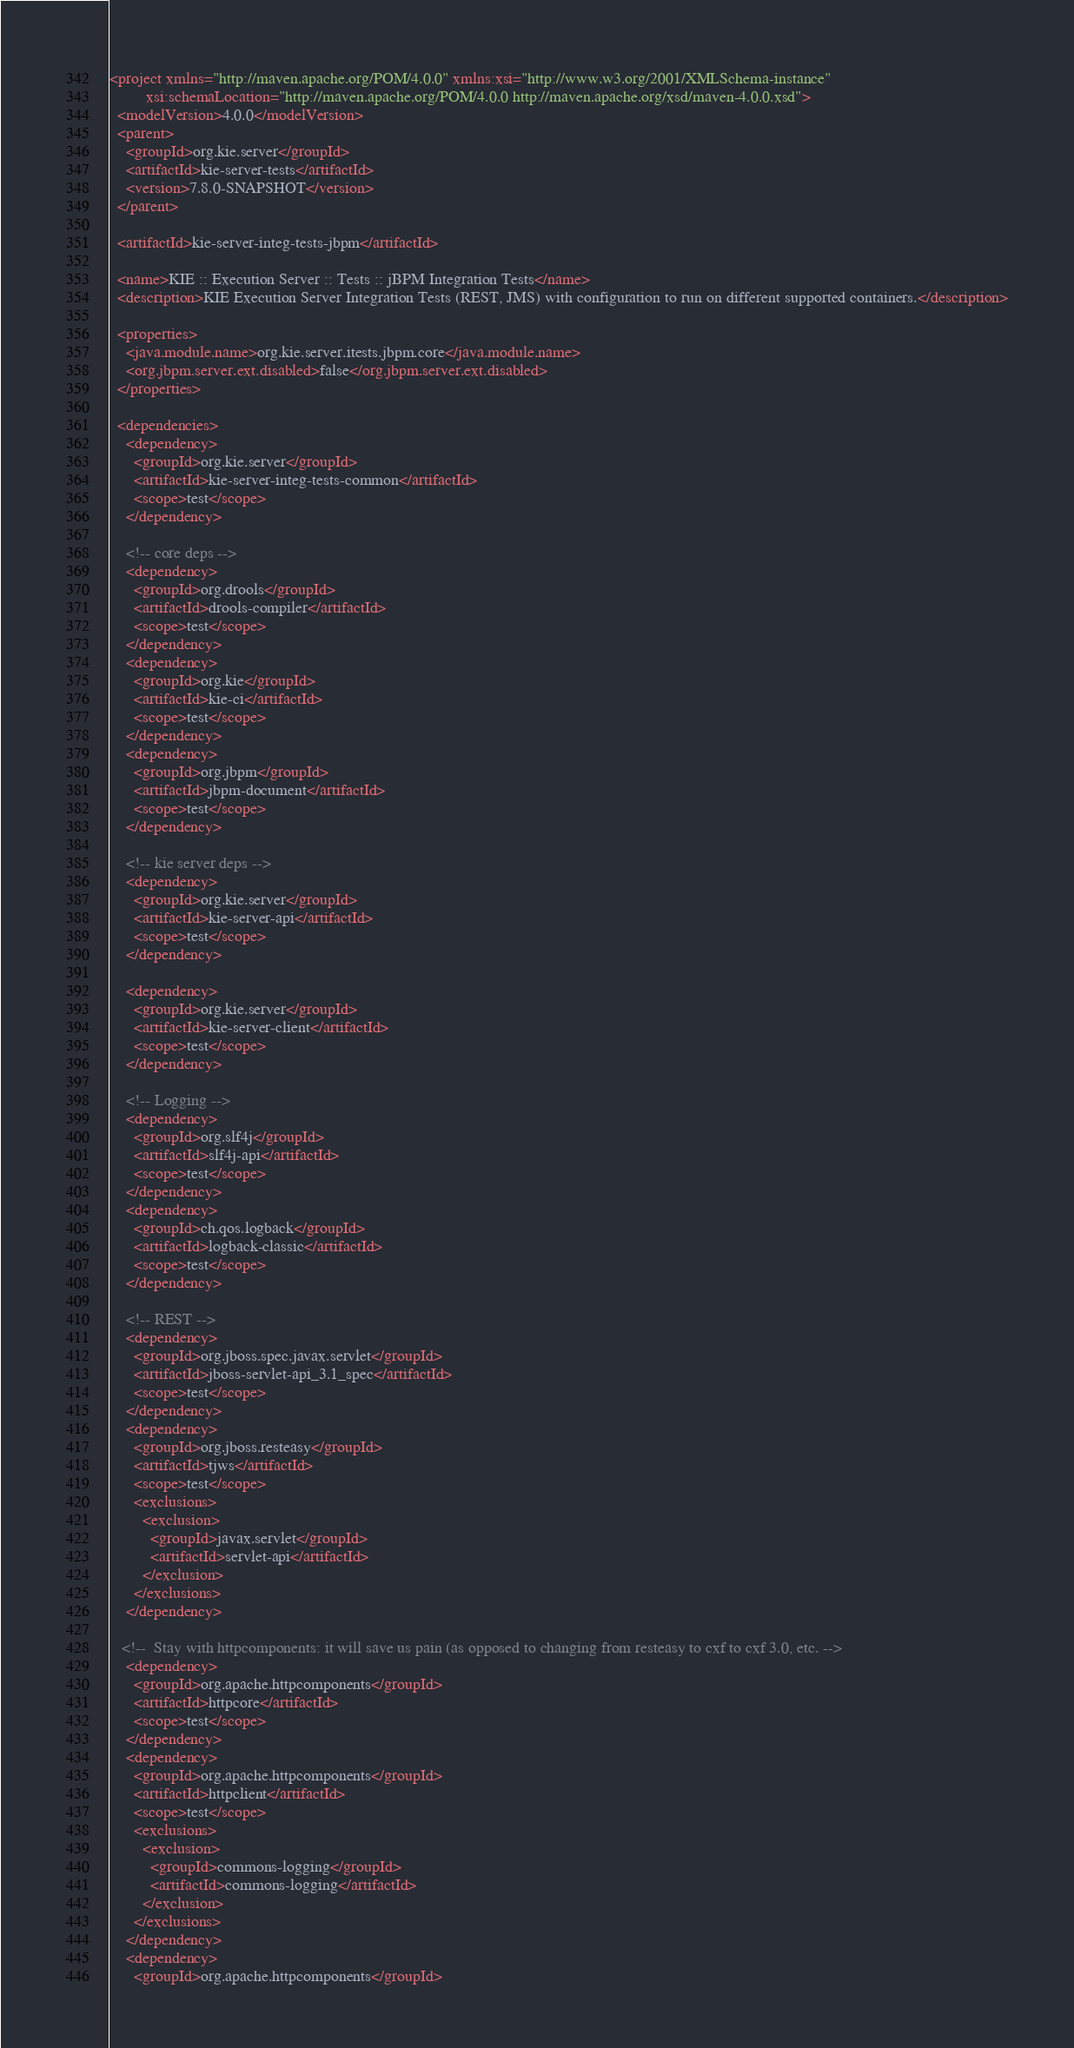<code> <loc_0><loc_0><loc_500><loc_500><_XML_><project xmlns="http://maven.apache.org/POM/4.0.0" xmlns:xsi="http://www.w3.org/2001/XMLSchema-instance"
         xsi:schemaLocation="http://maven.apache.org/POM/4.0.0 http://maven.apache.org/xsd/maven-4.0.0.xsd">
  <modelVersion>4.0.0</modelVersion>
  <parent>
    <groupId>org.kie.server</groupId>
    <artifactId>kie-server-tests</artifactId>
    <version>7.8.0-SNAPSHOT</version>
  </parent>

  <artifactId>kie-server-integ-tests-jbpm</artifactId>

  <name>KIE :: Execution Server :: Tests :: jBPM Integration Tests</name>
  <description>KIE Execution Server Integration Tests (REST, JMS) with configuration to run on different supported containers.</description>

  <properties>
    <java.module.name>org.kie.server.itests.jbpm.core</java.module.name>
    <org.jbpm.server.ext.disabled>false</org.jbpm.server.ext.disabled>
  </properties>

  <dependencies>
    <dependency>
      <groupId>org.kie.server</groupId>
      <artifactId>kie-server-integ-tests-common</artifactId>
      <scope>test</scope>
    </dependency>
    
    <!-- core deps -->
    <dependency>
      <groupId>org.drools</groupId>
      <artifactId>drools-compiler</artifactId>
      <scope>test</scope>
    </dependency>
    <dependency>
      <groupId>org.kie</groupId>
      <artifactId>kie-ci</artifactId>
      <scope>test</scope>
    </dependency>
    <dependency>
      <groupId>org.jbpm</groupId>
      <artifactId>jbpm-document</artifactId>
      <scope>test</scope>
    </dependency>
    
    <!-- kie server deps -->
    <dependency>
      <groupId>org.kie.server</groupId>
      <artifactId>kie-server-api</artifactId>
      <scope>test</scope>
    </dependency>

    <dependency>
      <groupId>org.kie.server</groupId>
      <artifactId>kie-server-client</artifactId>
      <scope>test</scope>
    </dependency>

    <!-- Logging -->
    <dependency>
      <groupId>org.slf4j</groupId>
      <artifactId>slf4j-api</artifactId>
      <scope>test</scope>
    </dependency>
    <dependency>
      <groupId>ch.qos.logback</groupId>
      <artifactId>logback-classic</artifactId>
      <scope>test</scope>
    </dependency>

    <!-- REST --> 
    <dependency>
      <groupId>org.jboss.spec.javax.servlet</groupId>
      <artifactId>jboss-servlet-api_3.1_spec</artifactId>
      <scope>test</scope>
    </dependency>
    <dependency>
      <groupId>org.jboss.resteasy</groupId>
      <artifactId>tjws</artifactId>
      <scope>test</scope>
      <exclusions>
        <exclusion>
          <groupId>javax.servlet</groupId>
          <artifactId>servlet-api</artifactId>
        </exclusion>
      </exclusions>
    </dependency>

   <!--  Stay with httpcomponents: it will save us pain (as opposed to changing from resteasy to cxf to cxf 3.0, etc. --> 
    <dependency>
      <groupId>org.apache.httpcomponents</groupId>
      <artifactId>httpcore</artifactId>
      <scope>test</scope>
    </dependency>
    <dependency>
      <groupId>org.apache.httpcomponents</groupId>
      <artifactId>httpclient</artifactId>
      <scope>test</scope>
      <exclusions>
        <exclusion>
          <groupId>commons-logging</groupId>
          <artifactId>commons-logging</artifactId>
        </exclusion>
      </exclusions>
    </dependency>
    <dependency>
      <groupId>org.apache.httpcomponents</groupId></code> 